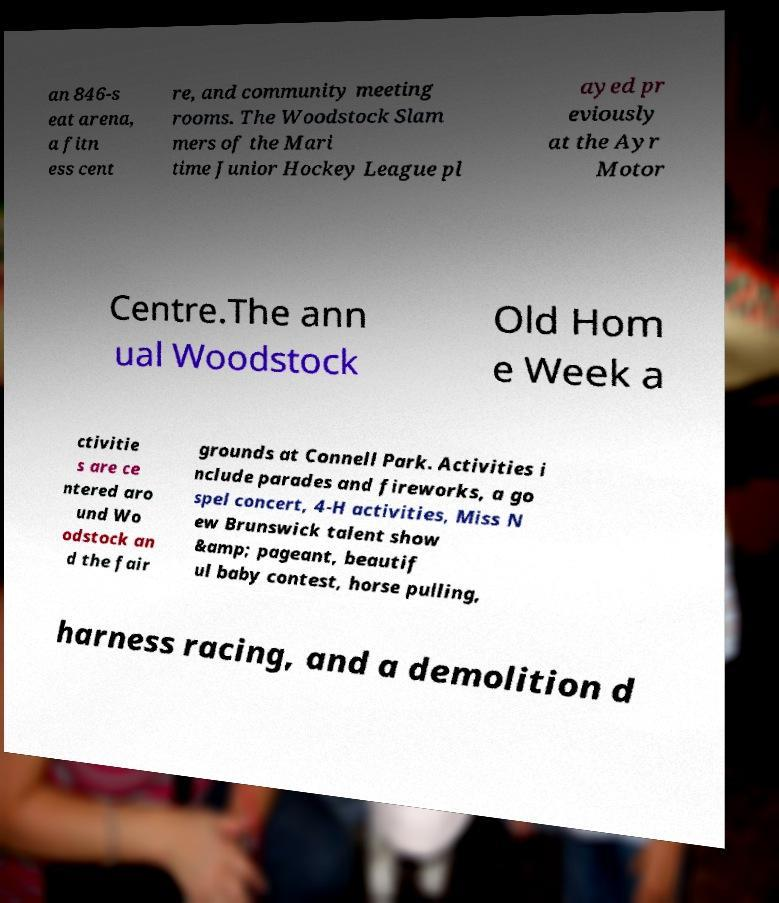I need the written content from this picture converted into text. Can you do that? an 846-s eat arena, a fitn ess cent re, and community meeting rooms. The Woodstock Slam mers of the Mari time Junior Hockey League pl ayed pr eviously at the Ayr Motor Centre.The ann ual Woodstock Old Hom e Week a ctivitie s are ce ntered aro und Wo odstock an d the fair grounds at Connell Park. Activities i nclude parades and fireworks, a go spel concert, 4-H activities, Miss N ew Brunswick talent show &amp; pageant, beautif ul baby contest, horse pulling, harness racing, and a demolition d 